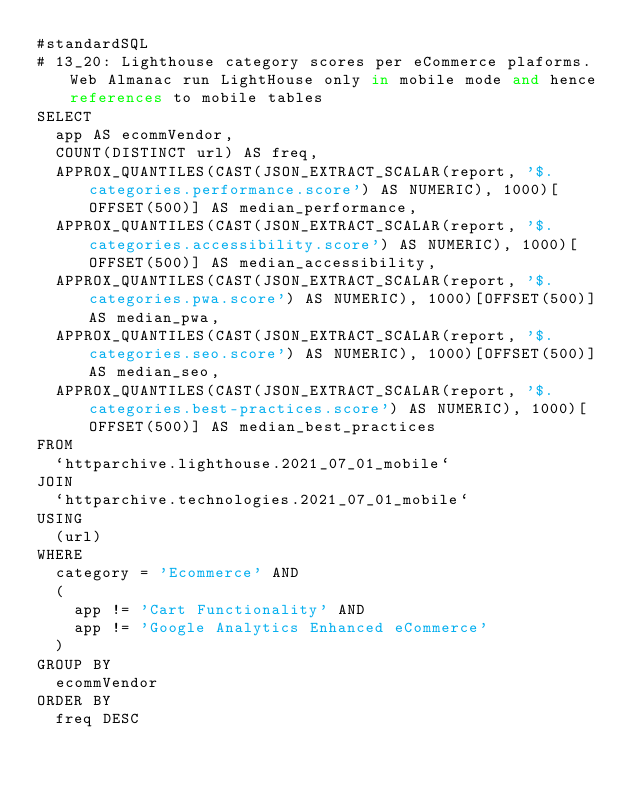<code> <loc_0><loc_0><loc_500><loc_500><_SQL_>#standardSQL
# 13_20: Lighthouse category scores per eCommerce plaforms. Web Almanac run LightHouse only in mobile mode and hence references to mobile tables
SELECT
  app AS ecommVendor,
  COUNT(DISTINCT url) AS freq,
  APPROX_QUANTILES(CAST(JSON_EXTRACT_SCALAR(report, '$.categories.performance.score') AS NUMERIC), 1000)[OFFSET(500)] AS median_performance,
  APPROX_QUANTILES(CAST(JSON_EXTRACT_SCALAR(report, '$.categories.accessibility.score') AS NUMERIC), 1000)[OFFSET(500)] AS median_accessibility,
  APPROX_QUANTILES(CAST(JSON_EXTRACT_SCALAR(report, '$.categories.pwa.score') AS NUMERIC), 1000)[OFFSET(500)] AS median_pwa,
  APPROX_QUANTILES(CAST(JSON_EXTRACT_SCALAR(report, '$.categories.seo.score') AS NUMERIC), 1000)[OFFSET(500)] AS median_seo,
  APPROX_QUANTILES(CAST(JSON_EXTRACT_SCALAR(report, '$.categories.best-practices.score') AS NUMERIC), 1000)[OFFSET(500)] AS median_best_practices
FROM
  `httparchive.lighthouse.2021_07_01_mobile`
JOIN
  `httparchive.technologies.2021_07_01_mobile`
USING
  (url)
WHERE
  category = 'Ecommerce' AND
  (
    app != 'Cart Functionality' AND
    app != 'Google Analytics Enhanced eCommerce'
  )
GROUP BY
  ecommVendor
ORDER BY
  freq DESC
</code> 